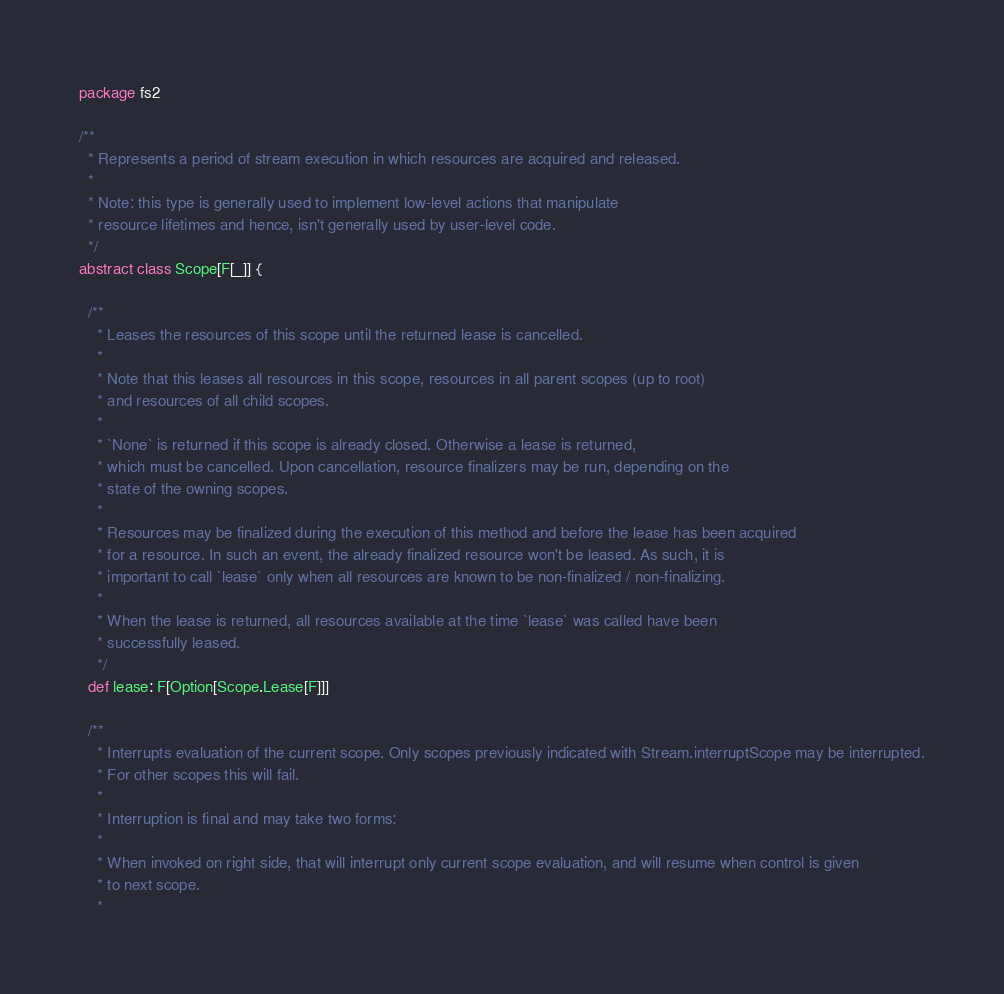<code> <loc_0><loc_0><loc_500><loc_500><_Scala_>package fs2

/**
  * Represents a period of stream execution in which resources are acquired and released.
  *
  * Note: this type is generally used to implement low-level actions that manipulate
  * resource lifetimes and hence, isn't generally used by user-level code.
  */
abstract class Scope[F[_]] {

  /**
    * Leases the resources of this scope until the returned lease is cancelled.
    *
    * Note that this leases all resources in this scope, resources in all parent scopes (up to root)
    * and resources of all child scopes.
    *
    * `None` is returned if this scope is already closed. Otherwise a lease is returned,
    * which must be cancelled. Upon cancellation, resource finalizers may be run, depending on the
    * state of the owning scopes.
    *
    * Resources may be finalized during the execution of this method and before the lease has been acquired
    * for a resource. In such an event, the already finalized resource won't be leased. As such, it is
    * important to call `lease` only when all resources are known to be non-finalized / non-finalizing.
    *
    * When the lease is returned, all resources available at the time `lease` was called have been
    * successfully leased.
    */
  def lease: F[Option[Scope.Lease[F]]]

  /**
    * Interrupts evaluation of the current scope. Only scopes previously indicated with Stream.interruptScope may be interrupted.
    * For other scopes this will fail.
    *
    * Interruption is final and may take two forms:
    *
    * When invoked on right side, that will interrupt only current scope evaluation, and will resume when control is given
    * to next scope.
    *</code> 